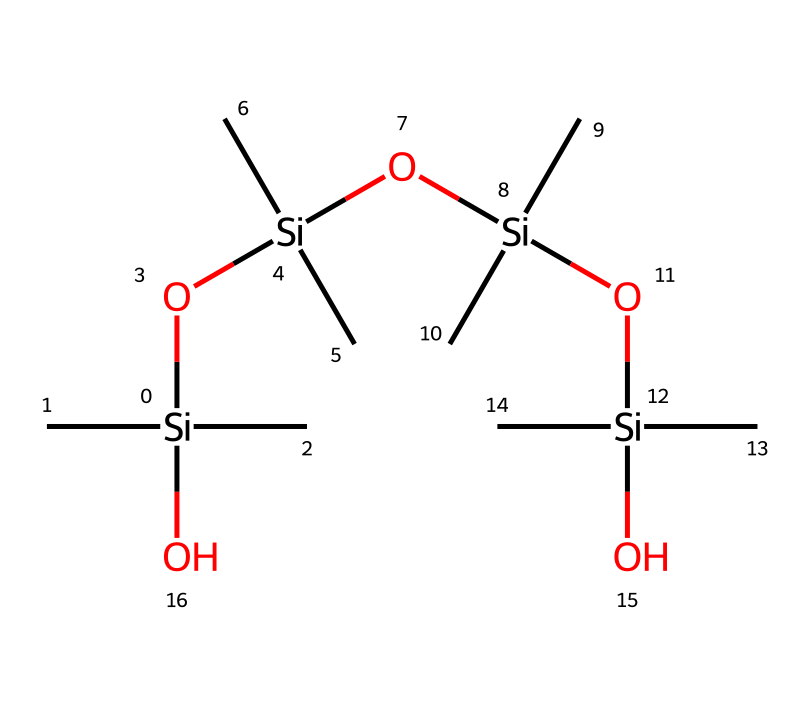How many silicon atoms are in this compound? The SMILES representation shows multiple instances of silicon symbols (Si). By counting the occurrences, we find there are four silicon atoms present in total.
Answer: four What type of bonding is predominant in the siloxane framework? The structural representation involves silicon-oxygen (Si-O) linkages, which are characteristic of siloxane compounds. These Si-O bonds form the backbone of the structure.
Answer: Si-O What functional groups are present in this compound? The compound includes silanol groups due to the presence of Si-O-H structures. Since the representation does not explicitly show hydrogen atoms attached, we identify these groups based on connectivity and typical behaviors of siloxanes.
Answer: silanol How many oxygen atoms are present in the compound? By examining the SMILES code, we see that there are four occurrences of the oxygen symbol (O) associated with the siloxane structure, indicating the total count of oxygen atoms.
Answer: four What is the main structural characteristic of this compound allowing for lens coating applications? The compound’s repeating siloxane (Si-O) units provide flexibility and transparency, which are essential qualities for lens coatings to enhance optical performance without compromising durability.
Answer: flexibility and transparency What is the abbreviation for the class of compounds that includes this structure? The class of compounds containing silicon, such as this one, is known by the term 'organosilicon'. The name reflects the combination of organic and silicone elements in the structure.
Answer: organosilicon What type of synthesis method is commonly used to create siloxane materials? Siloxane materials like the one represented are typically synthesized through hydrolysis and condensation reactions of silanes, leading to the formation of siloxane linkages. This process is fundamental in producing the desired polymer structures.
Answer: hydrolysis and condensation 